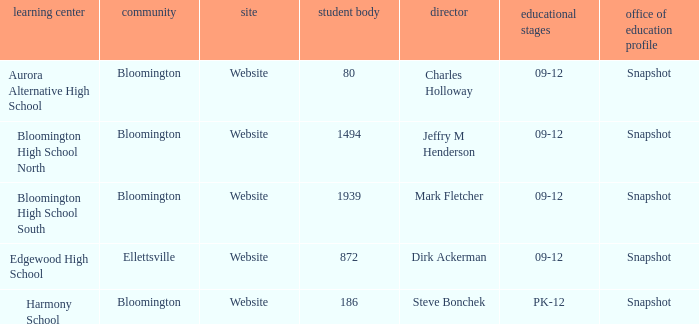Who's the principal of Edgewood High School?/ Dirk Ackerman. 